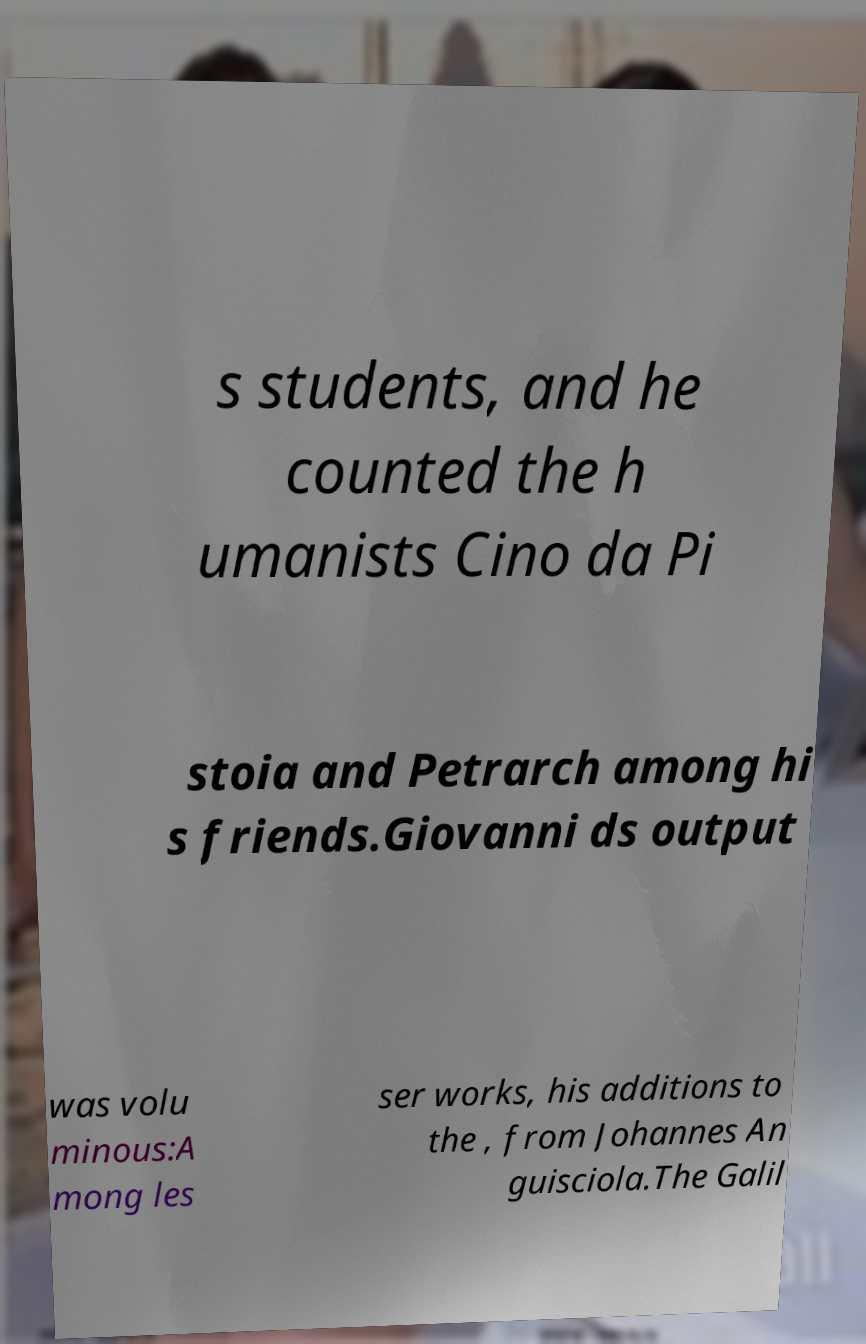What messages or text are displayed in this image? I need them in a readable, typed format. s students, and he counted the h umanists Cino da Pi stoia and Petrarch among hi s friends.Giovanni ds output was volu minous:A mong les ser works, his additions to the , from Johannes An guisciola.The Galil 